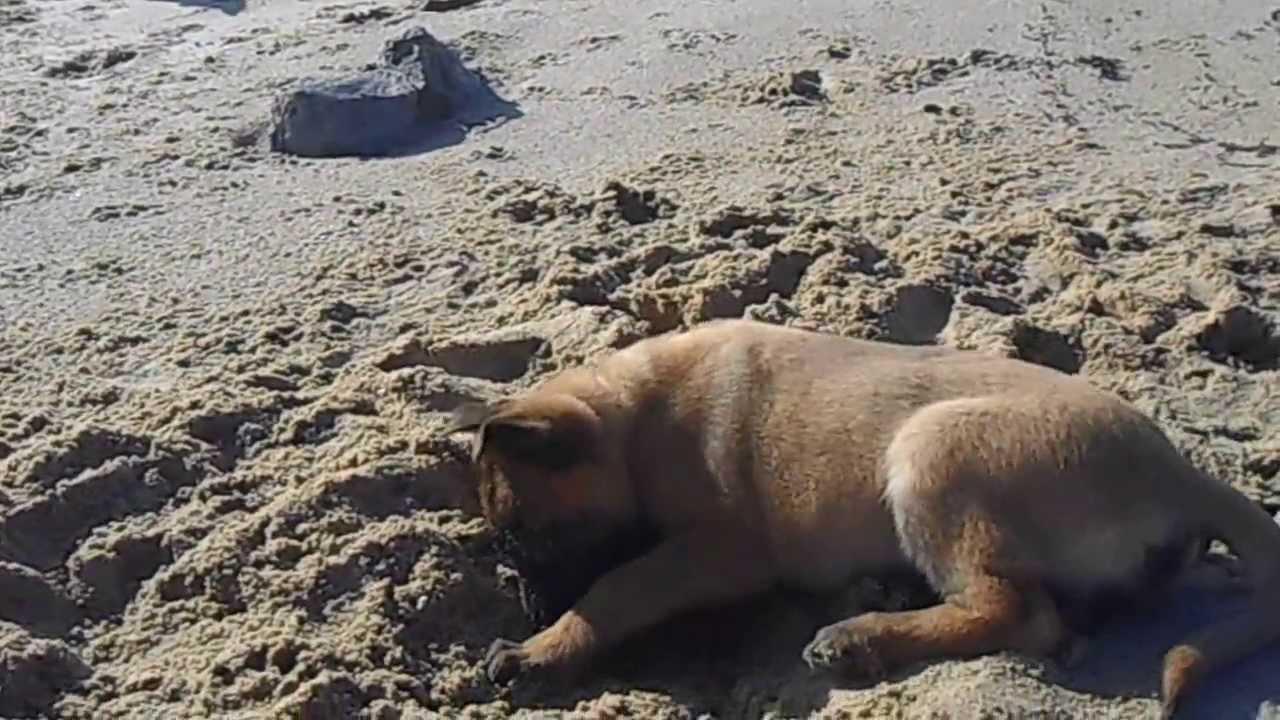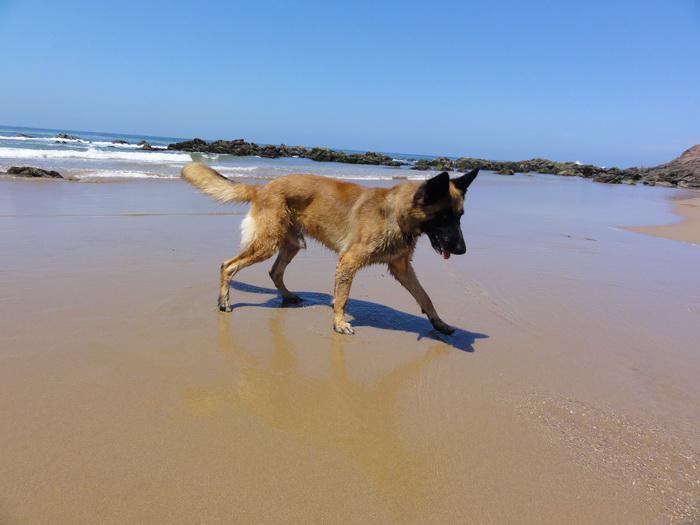The first image is the image on the left, the second image is the image on the right. For the images shown, is this caption "A dog with upright ears is bounding across the sand, and the ocean is visible in at least one image." true? Answer yes or no. No. The first image is the image on the left, the second image is the image on the right. Considering the images on both sides, is "A single dog is standing legs and facing right in one of the images." valid? Answer yes or no. Yes. 